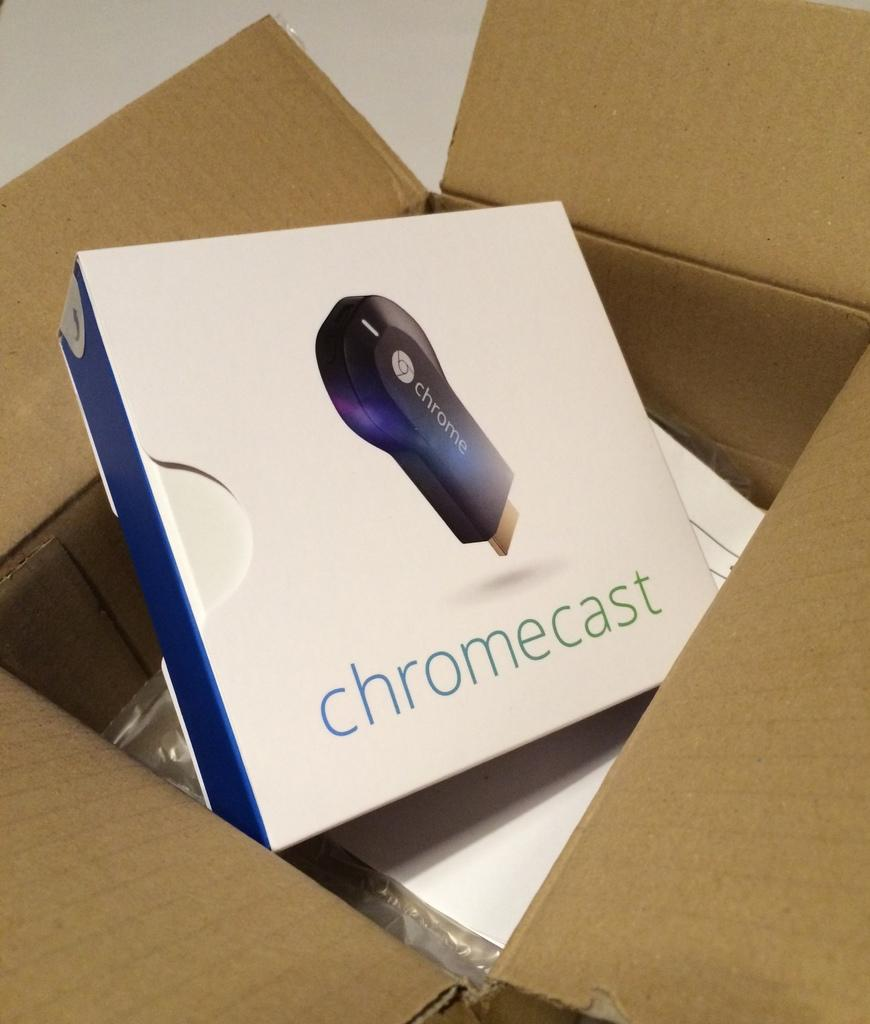<image>
Write a terse but informative summary of the picture. A Chromecast box is sitting inside a brown cardboard box. 